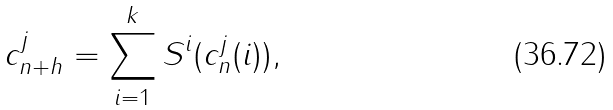<formula> <loc_0><loc_0><loc_500><loc_500>c ^ { j } _ { n + h } = \sum _ { i = 1 } ^ { k } S ^ { i } ( c ^ { j } _ { n } ( i ) ) ,</formula> 